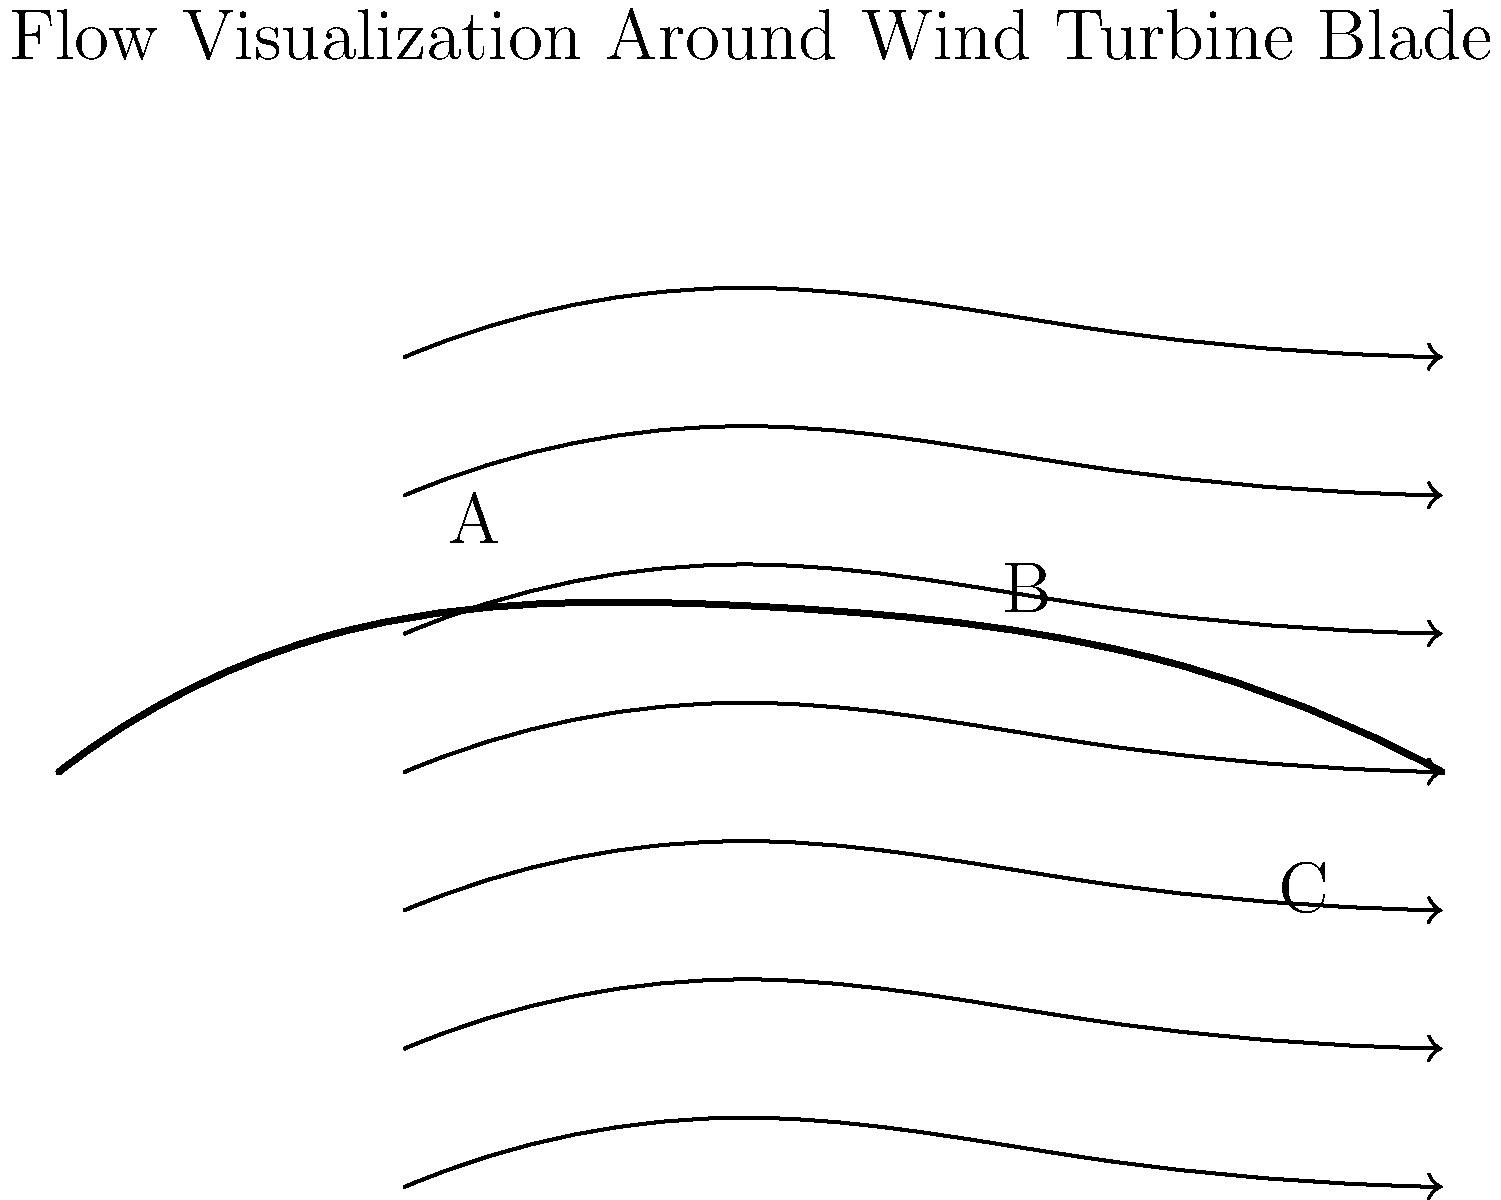Based on the flow visualization pattern around the wind turbine blade shown in the diagram, at which point is the flow velocity likely to be highest, and why? To determine the point of highest flow velocity, we need to analyze the streamlines around the airfoil:

1. Streamline spacing: The closer the streamlines, the higher the velocity. This is due to the principle of mass conservation in fluid mechanics.

2. Airfoil shape: The curvature of the airfoil affects the flow velocity due to the Bernoulli principle.

3. Analyzing the points:
   A: At the leading edge, streamlines begin to spread, indicating a decrease in velocity.
   B: Near the top surface, streamlines are closest together, suggesting the highest velocity.
   C: At the trailing edge, streamlines are spreading out again, indicating a velocity decrease.

4. Bernoulli's principle: As the fluid accelerates over the curved upper surface of the airfoil, the pressure decreases, and velocity increases to maintain constant total energy.

5. Point of maximum thickness: The highest velocity typically occurs slightly behind the point of maximum thickness on the upper surface, which corresponds to point B in this diagram.

Therefore, the flow velocity is likely to be highest at point B due to the combination of streamline convergence and the airfoil's shape effect on pressure distribution.
Answer: Point B 